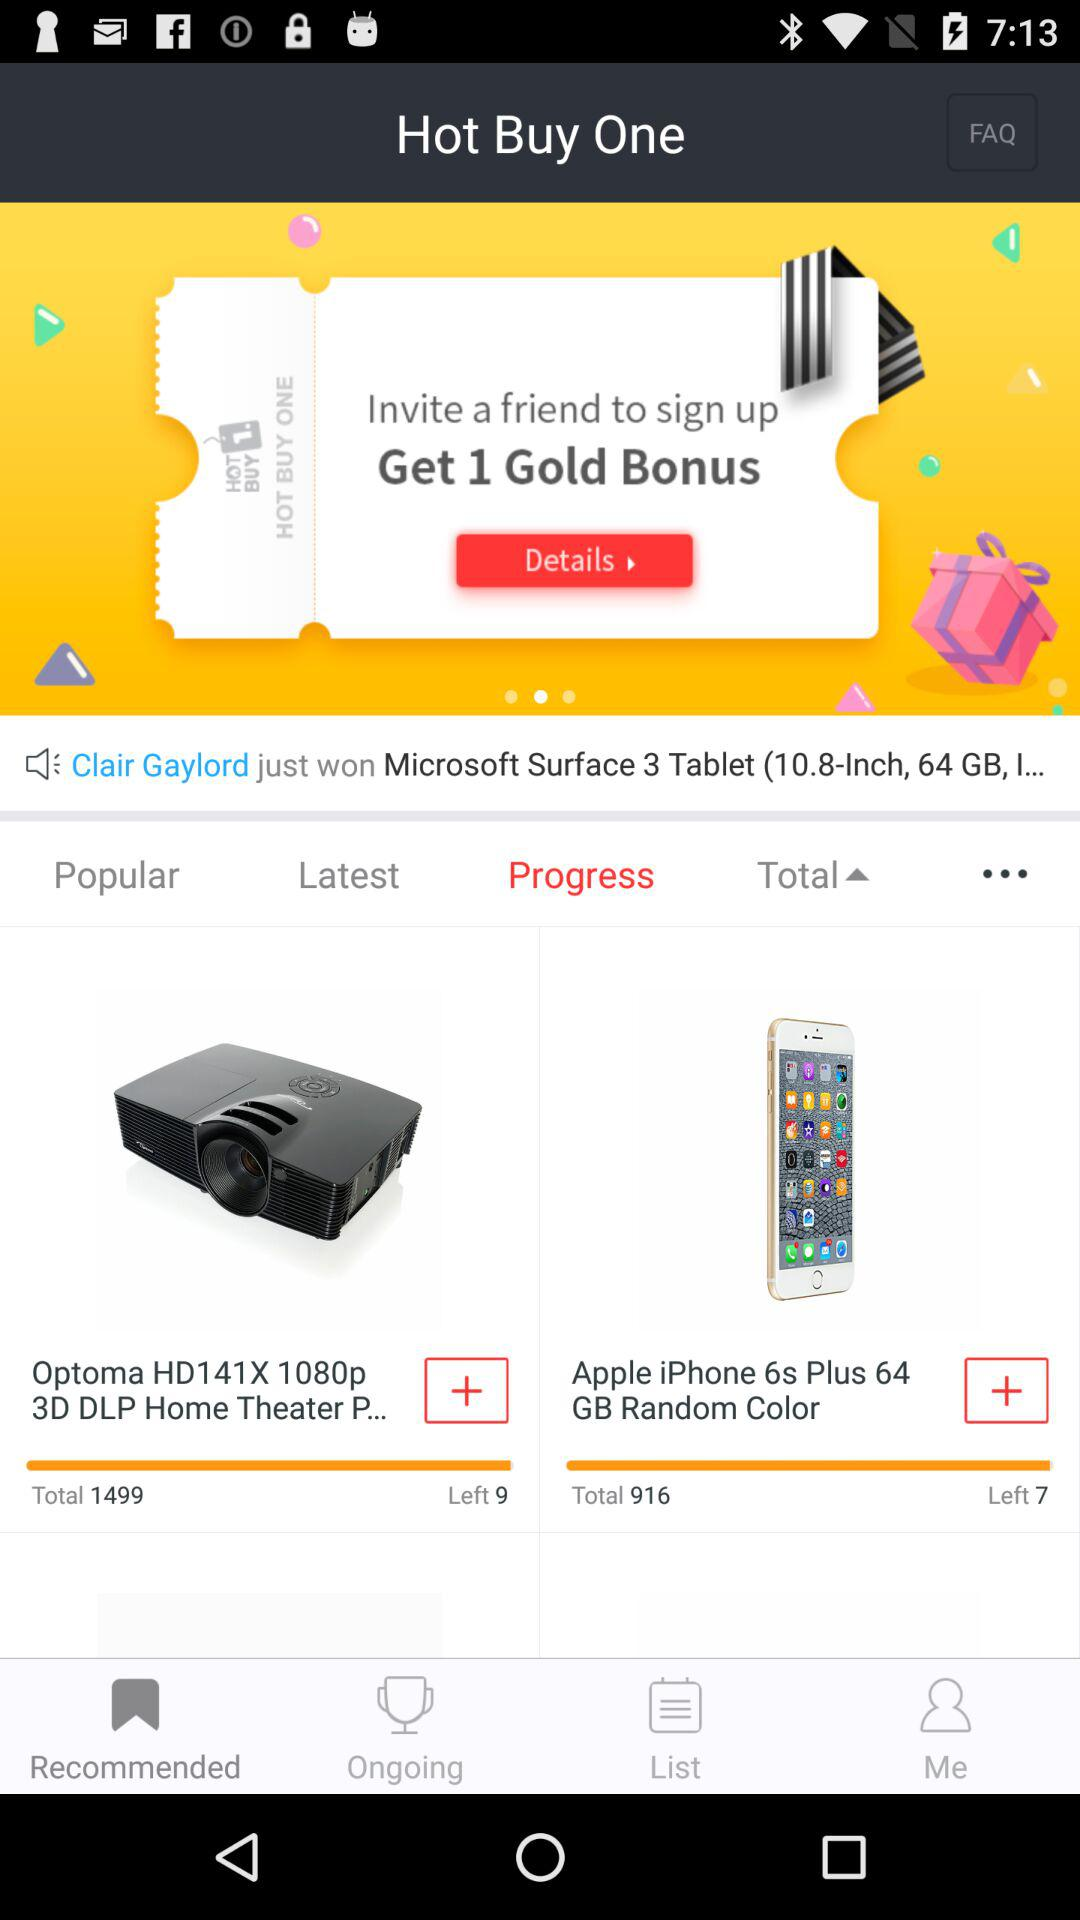How many home theaters are left? There are 9 home theaters left. 